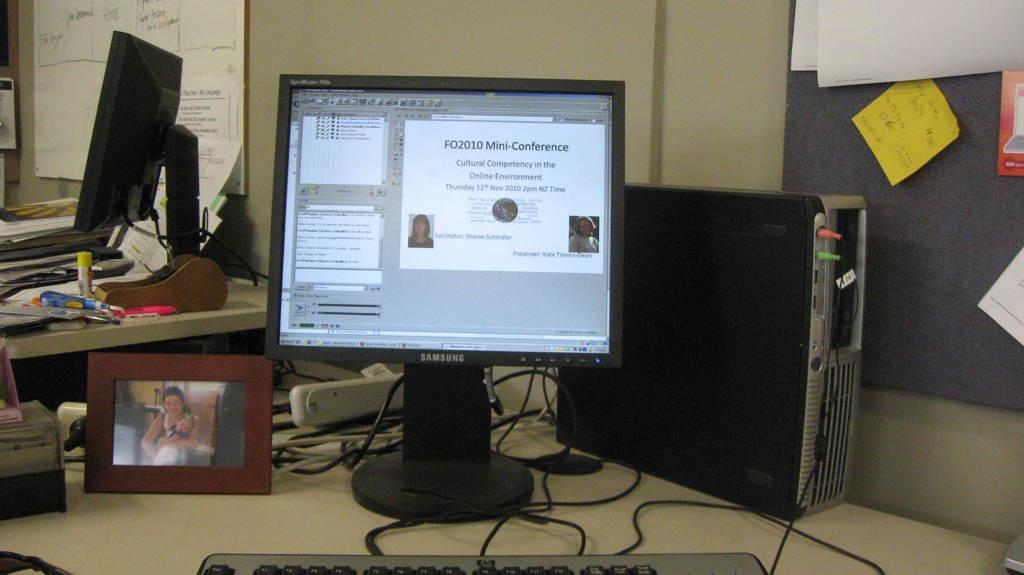<image>
Present a compact description of the photo's key features. A computer screen with a slide regarding a mini conference 